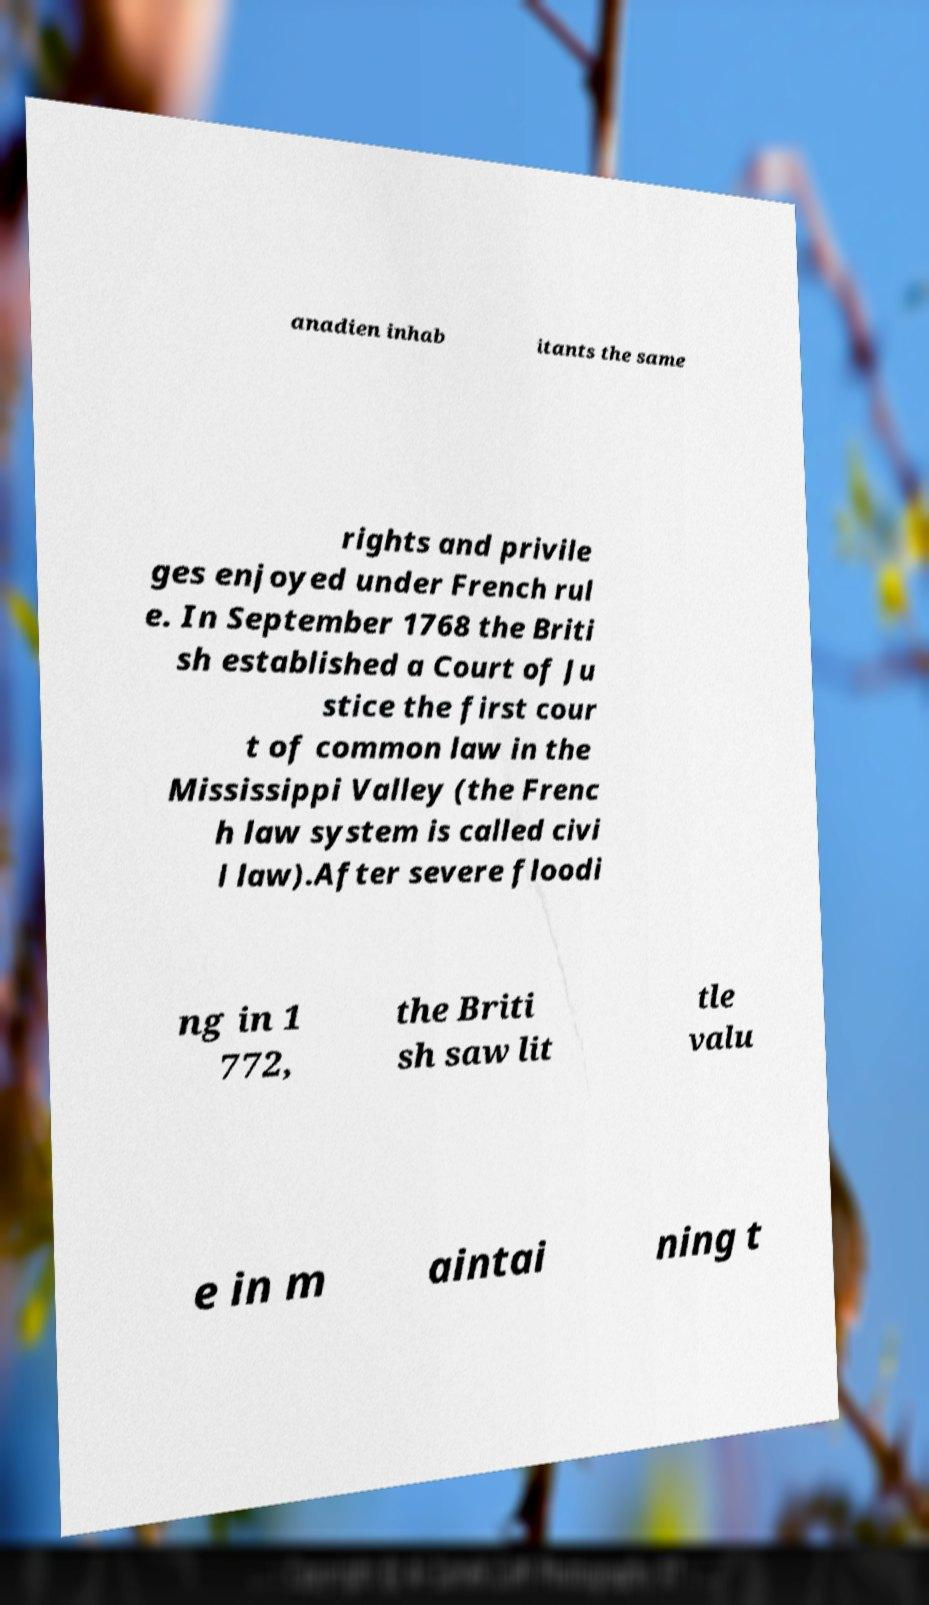Could you assist in decoding the text presented in this image and type it out clearly? anadien inhab itants the same rights and privile ges enjoyed under French rul e. In September 1768 the Briti sh established a Court of Ju stice the first cour t of common law in the Mississippi Valley (the Frenc h law system is called civi l law).After severe floodi ng in 1 772, the Briti sh saw lit tle valu e in m aintai ning t 